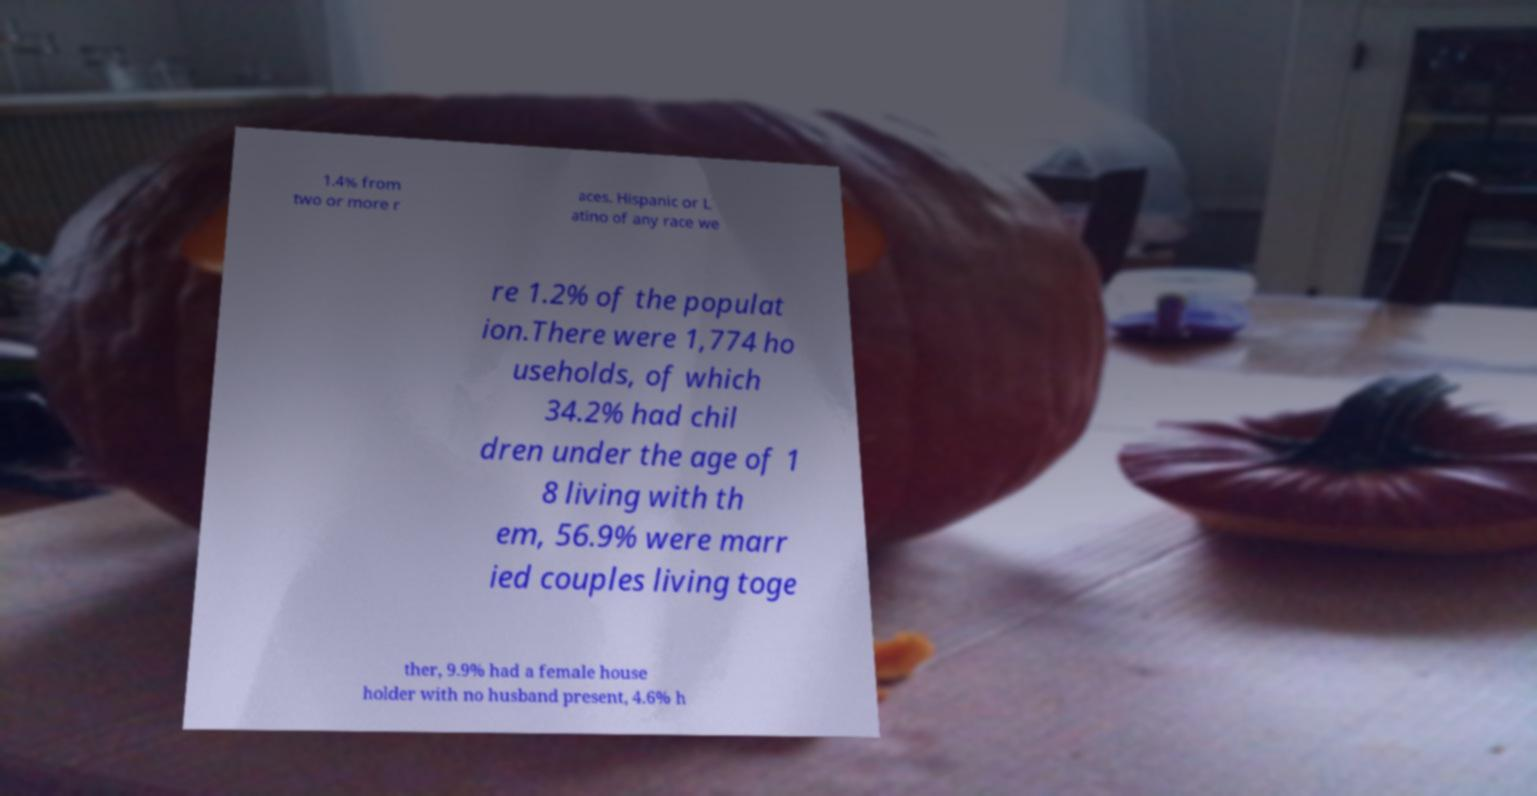There's text embedded in this image that I need extracted. Can you transcribe it verbatim? 1.4% from two or more r aces. Hispanic or L atino of any race we re 1.2% of the populat ion.There were 1,774 ho useholds, of which 34.2% had chil dren under the age of 1 8 living with th em, 56.9% were marr ied couples living toge ther, 9.9% had a female house holder with no husband present, 4.6% h 